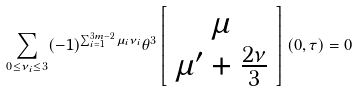<formula> <loc_0><loc_0><loc_500><loc_500>\sum _ { 0 \leq \nu _ { i } \leq 3 } ( - 1 ) ^ { \sum _ { i = 1 } ^ { 3 m - 2 } \mu _ { i } \nu _ { i } } \theta ^ { 3 } \left [ \begin{array} { c c } \mu \\ \mu ^ { \prime } + \frac { 2 \nu } { 3 } \end{array} \right ] ( 0 , \tau ) = 0</formula> 